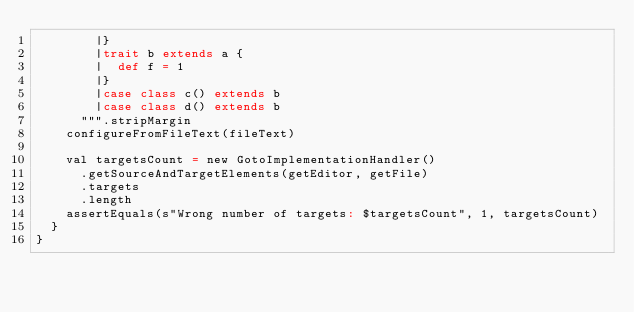<code> <loc_0><loc_0><loc_500><loc_500><_Scala_>        |}
        |trait b extends a {
        |  def f = 1
        |}
        |case class c() extends b
        |case class d() extends b
      """.stripMargin
    configureFromFileText(fileText)

    val targetsCount = new GotoImplementationHandler()
      .getSourceAndTargetElements(getEditor, getFile)
      .targets
      .length
    assertEquals(s"Wrong number of targets: $targetsCount", 1, targetsCount)
  }
}
</code> 